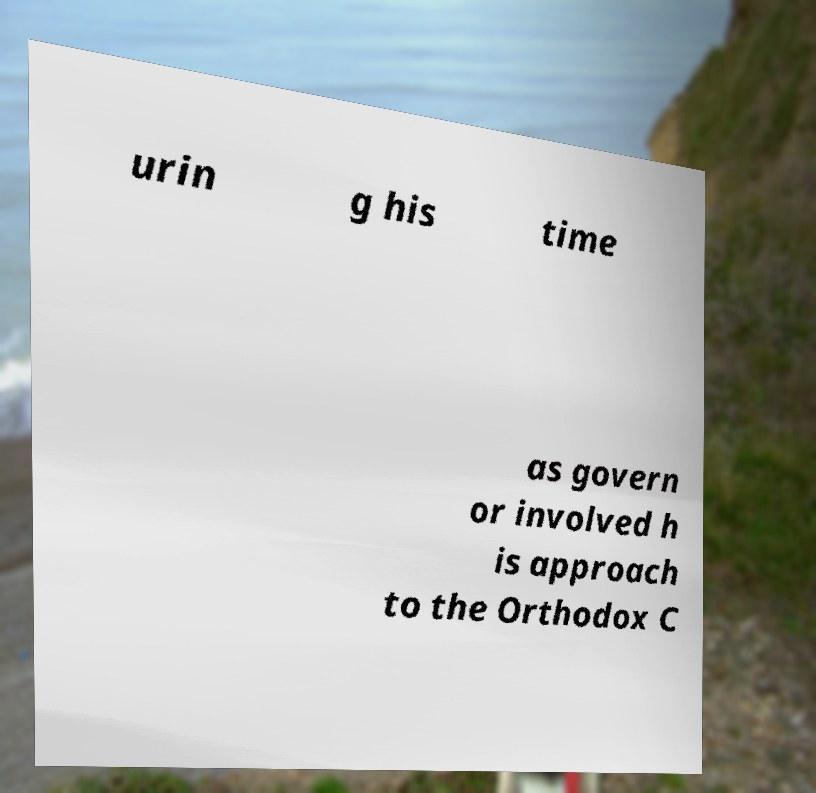Could you assist in decoding the text presented in this image and type it out clearly? urin g his time as govern or involved h is approach to the Orthodox C 